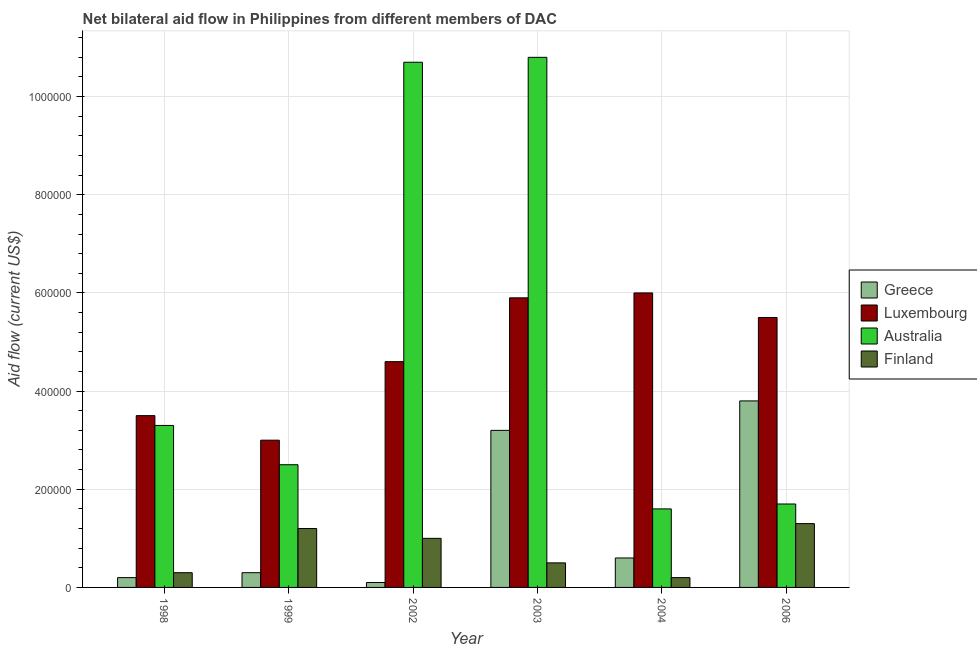Are the number of bars on each tick of the X-axis equal?
Give a very brief answer. Yes. How many bars are there on the 1st tick from the left?
Give a very brief answer. 4. What is the label of the 3rd group of bars from the left?
Your answer should be very brief. 2002. What is the amount of aid given by luxembourg in 2004?
Provide a short and direct response. 6.00e+05. Across all years, what is the maximum amount of aid given by finland?
Offer a very short reply. 1.30e+05. Across all years, what is the minimum amount of aid given by australia?
Offer a terse response. 1.60e+05. What is the total amount of aid given by greece in the graph?
Your response must be concise. 8.20e+05. What is the difference between the amount of aid given by luxembourg in 2002 and that in 2004?
Your response must be concise. -1.40e+05. What is the difference between the amount of aid given by luxembourg in 1998 and the amount of aid given by greece in 2006?
Give a very brief answer. -2.00e+05. What is the average amount of aid given by australia per year?
Provide a succinct answer. 5.10e+05. In the year 2004, what is the difference between the amount of aid given by australia and amount of aid given by finland?
Your answer should be compact. 0. In how many years, is the amount of aid given by finland greater than 960000 US$?
Provide a short and direct response. 0. What is the ratio of the amount of aid given by finland in 1998 to that in 2006?
Ensure brevity in your answer.  0.23. Is the amount of aid given by australia in 2003 less than that in 2004?
Offer a very short reply. No. Is the difference between the amount of aid given by finland in 2003 and 2006 greater than the difference between the amount of aid given by luxembourg in 2003 and 2006?
Ensure brevity in your answer.  No. What is the difference between the highest and the lowest amount of aid given by australia?
Your response must be concise. 9.20e+05. In how many years, is the amount of aid given by australia greater than the average amount of aid given by australia taken over all years?
Your answer should be very brief. 2. What does the 2nd bar from the left in 1999 represents?
Your response must be concise. Luxembourg. What does the 1st bar from the right in 1999 represents?
Your answer should be very brief. Finland. Is it the case that in every year, the sum of the amount of aid given by greece and amount of aid given by luxembourg is greater than the amount of aid given by australia?
Offer a terse response. No. Are all the bars in the graph horizontal?
Keep it short and to the point. No. How many years are there in the graph?
Offer a very short reply. 6. What is the difference between two consecutive major ticks on the Y-axis?
Your response must be concise. 2.00e+05. Are the values on the major ticks of Y-axis written in scientific E-notation?
Your answer should be compact. No. Does the graph contain any zero values?
Your response must be concise. No. Does the graph contain grids?
Your response must be concise. Yes. Where does the legend appear in the graph?
Give a very brief answer. Center right. How many legend labels are there?
Offer a very short reply. 4. What is the title of the graph?
Your answer should be compact. Net bilateral aid flow in Philippines from different members of DAC. What is the label or title of the X-axis?
Provide a succinct answer. Year. What is the label or title of the Y-axis?
Your answer should be compact. Aid flow (current US$). What is the Aid flow (current US$) of Greece in 1998?
Your answer should be very brief. 2.00e+04. What is the Aid flow (current US$) of Luxembourg in 1998?
Give a very brief answer. 3.50e+05. What is the Aid flow (current US$) of Luxembourg in 1999?
Offer a very short reply. 3.00e+05. What is the Aid flow (current US$) in Australia in 1999?
Provide a short and direct response. 2.50e+05. What is the Aid flow (current US$) of Finland in 1999?
Your answer should be very brief. 1.20e+05. What is the Aid flow (current US$) of Luxembourg in 2002?
Offer a terse response. 4.60e+05. What is the Aid flow (current US$) of Australia in 2002?
Keep it short and to the point. 1.07e+06. What is the Aid flow (current US$) in Luxembourg in 2003?
Make the answer very short. 5.90e+05. What is the Aid flow (current US$) in Australia in 2003?
Give a very brief answer. 1.08e+06. What is the Aid flow (current US$) of Finland in 2004?
Make the answer very short. 2.00e+04. What is the Aid flow (current US$) of Greece in 2006?
Offer a terse response. 3.80e+05. What is the Aid flow (current US$) of Australia in 2006?
Ensure brevity in your answer.  1.70e+05. What is the Aid flow (current US$) in Finland in 2006?
Provide a succinct answer. 1.30e+05. Across all years, what is the maximum Aid flow (current US$) in Luxembourg?
Your answer should be compact. 6.00e+05. Across all years, what is the maximum Aid flow (current US$) in Australia?
Your answer should be compact. 1.08e+06. Across all years, what is the minimum Aid flow (current US$) of Greece?
Ensure brevity in your answer.  10000. Across all years, what is the minimum Aid flow (current US$) in Luxembourg?
Keep it short and to the point. 3.00e+05. Across all years, what is the minimum Aid flow (current US$) in Australia?
Give a very brief answer. 1.60e+05. What is the total Aid flow (current US$) in Greece in the graph?
Your answer should be compact. 8.20e+05. What is the total Aid flow (current US$) of Luxembourg in the graph?
Offer a very short reply. 2.85e+06. What is the total Aid flow (current US$) in Australia in the graph?
Offer a very short reply. 3.06e+06. What is the total Aid flow (current US$) of Finland in the graph?
Provide a succinct answer. 4.50e+05. What is the difference between the Aid flow (current US$) of Luxembourg in 1998 and that in 1999?
Make the answer very short. 5.00e+04. What is the difference between the Aid flow (current US$) of Finland in 1998 and that in 1999?
Give a very brief answer. -9.00e+04. What is the difference between the Aid flow (current US$) of Australia in 1998 and that in 2002?
Your answer should be compact. -7.40e+05. What is the difference between the Aid flow (current US$) in Australia in 1998 and that in 2003?
Provide a succinct answer. -7.50e+05. What is the difference between the Aid flow (current US$) of Luxembourg in 1998 and that in 2004?
Offer a very short reply. -2.50e+05. What is the difference between the Aid flow (current US$) of Finland in 1998 and that in 2004?
Offer a terse response. 10000. What is the difference between the Aid flow (current US$) in Greece in 1998 and that in 2006?
Give a very brief answer. -3.60e+05. What is the difference between the Aid flow (current US$) of Luxembourg in 1998 and that in 2006?
Offer a terse response. -2.00e+05. What is the difference between the Aid flow (current US$) in Australia in 1998 and that in 2006?
Keep it short and to the point. 1.60e+05. What is the difference between the Aid flow (current US$) in Greece in 1999 and that in 2002?
Provide a succinct answer. 2.00e+04. What is the difference between the Aid flow (current US$) of Australia in 1999 and that in 2002?
Keep it short and to the point. -8.20e+05. What is the difference between the Aid flow (current US$) in Finland in 1999 and that in 2002?
Ensure brevity in your answer.  2.00e+04. What is the difference between the Aid flow (current US$) in Australia in 1999 and that in 2003?
Give a very brief answer. -8.30e+05. What is the difference between the Aid flow (current US$) in Australia in 1999 and that in 2004?
Offer a very short reply. 9.00e+04. What is the difference between the Aid flow (current US$) in Greece in 1999 and that in 2006?
Your answer should be compact. -3.50e+05. What is the difference between the Aid flow (current US$) of Greece in 2002 and that in 2003?
Provide a short and direct response. -3.10e+05. What is the difference between the Aid flow (current US$) of Finland in 2002 and that in 2003?
Your answer should be compact. 5.00e+04. What is the difference between the Aid flow (current US$) of Luxembourg in 2002 and that in 2004?
Give a very brief answer. -1.40e+05. What is the difference between the Aid flow (current US$) in Australia in 2002 and that in 2004?
Provide a succinct answer. 9.10e+05. What is the difference between the Aid flow (current US$) in Greece in 2002 and that in 2006?
Give a very brief answer. -3.70e+05. What is the difference between the Aid flow (current US$) in Australia in 2002 and that in 2006?
Your answer should be very brief. 9.00e+05. What is the difference between the Aid flow (current US$) in Finland in 2002 and that in 2006?
Your response must be concise. -3.00e+04. What is the difference between the Aid flow (current US$) of Australia in 2003 and that in 2004?
Make the answer very short. 9.20e+05. What is the difference between the Aid flow (current US$) in Finland in 2003 and that in 2004?
Offer a very short reply. 3.00e+04. What is the difference between the Aid flow (current US$) in Australia in 2003 and that in 2006?
Offer a terse response. 9.10e+05. What is the difference between the Aid flow (current US$) in Greece in 2004 and that in 2006?
Provide a succinct answer. -3.20e+05. What is the difference between the Aid flow (current US$) in Australia in 2004 and that in 2006?
Your answer should be compact. -10000. What is the difference between the Aid flow (current US$) of Finland in 2004 and that in 2006?
Your response must be concise. -1.10e+05. What is the difference between the Aid flow (current US$) of Greece in 1998 and the Aid flow (current US$) of Luxembourg in 1999?
Provide a succinct answer. -2.80e+05. What is the difference between the Aid flow (current US$) of Greece in 1998 and the Aid flow (current US$) of Australia in 1999?
Keep it short and to the point. -2.30e+05. What is the difference between the Aid flow (current US$) of Luxembourg in 1998 and the Aid flow (current US$) of Australia in 1999?
Offer a terse response. 1.00e+05. What is the difference between the Aid flow (current US$) of Greece in 1998 and the Aid flow (current US$) of Luxembourg in 2002?
Make the answer very short. -4.40e+05. What is the difference between the Aid flow (current US$) of Greece in 1998 and the Aid flow (current US$) of Australia in 2002?
Provide a short and direct response. -1.05e+06. What is the difference between the Aid flow (current US$) in Luxembourg in 1998 and the Aid flow (current US$) in Australia in 2002?
Give a very brief answer. -7.20e+05. What is the difference between the Aid flow (current US$) in Luxembourg in 1998 and the Aid flow (current US$) in Finland in 2002?
Your response must be concise. 2.50e+05. What is the difference between the Aid flow (current US$) in Greece in 1998 and the Aid flow (current US$) in Luxembourg in 2003?
Offer a terse response. -5.70e+05. What is the difference between the Aid flow (current US$) in Greece in 1998 and the Aid flow (current US$) in Australia in 2003?
Offer a terse response. -1.06e+06. What is the difference between the Aid flow (current US$) of Luxembourg in 1998 and the Aid flow (current US$) of Australia in 2003?
Give a very brief answer. -7.30e+05. What is the difference between the Aid flow (current US$) in Luxembourg in 1998 and the Aid flow (current US$) in Finland in 2003?
Make the answer very short. 3.00e+05. What is the difference between the Aid flow (current US$) in Australia in 1998 and the Aid flow (current US$) in Finland in 2003?
Give a very brief answer. 2.80e+05. What is the difference between the Aid flow (current US$) of Greece in 1998 and the Aid flow (current US$) of Luxembourg in 2004?
Your response must be concise. -5.80e+05. What is the difference between the Aid flow (current US$) in Australia in 1998 and the Aid flow (current US$) in Finland in 2004?
Offer a terse response. 3.10e+05. What is the difference between the Aid flow (current US$) in Greece in 1998 and the Aid flow (current US$) in Luxembourg in 2006?
Offer a terse response. -5.30e+05. What is the difference between the Aid flow (current US$) in Greece in 1998 and the Aid flow (current US$) in Finland in 2006?
Give a very brief answer. -1.10e+05. What is the difference between the Aid flow (current US$) of Luxembourg in 1998 and the Aid flow (current US$) of Australia in 2006?
Your answer should be compact. 1.80e+05. What is the difference between the Aid flow (current US$) in Australia in 1998 and the Aid flow (current US$) in Finland in 2006?
Give a very brief answer. 2.00e+05. What is the difference between the Aid flow (current US$) of Greece in 1999 and the Aid flow (current US$) of Luxembourg in 2002?
Ensure brevity in your answer.  -4.30e+05. What is the difference between the Aid flow (current US$) in Greece in 1999 and the Aid flow (current US$) in Australia in 2002?
Keep it short and to the point. -1.04e+06. What is the difference between the Aid flow (current US$) in Luxembourg in 1999 and the Aid flow (current US$) in Australia in 2002?
Keep it short and to the point. -7.70e+05. What is the difference between the Aid flow (current US$) of Greece in 1999 and the Aid flow (current US$) of Luxembourg in 2003?
Provide a succinct answer. -5.60e+05. What is the difference between the Aid flow (current US$) of Greece in 1999 and the Aid flow (current US$) of Australia in 2003?
Keep it short and to the point. -1.05e+06. What is the difference between the Aid flow (current US$) in Greece in 1999 and the Aid flow (current US$) in Finland in 2003?
Your answer should be very brief. -2.00e+04. What is the difference between the Aid flow (current US$) in Luxembourg in 1999 and the Aid flow (current US$) in Australia in 2003?
Your answer should be compact. -7.80e+05. What is the difference between the Aid flow (current US$) in Greece in 1999 and the Aid flow (current US$) in Luxembourg in 2004?
Your response must be concise. -5.70e+05. What is the difference between the Aid flow (current US$) of Greece in 1999 and the Aid flow (current US$) of Australia in 2004?
Provide a short and direct response. -1.30e+05. What is the difference between the Aid flow (current US$) in Luxembourg in 1999 and the Aid flow (current US$) in Australia in 2004?
Provide a short and direct response. 1.40e+05. What is the difference between the Aid flow (current US$) in Australia in 1999 and the Aid flow (current US$) in Finland in 2004?
Offer a very short reply. 2.30e+05. What is the difference between the Aid flow (current US$) of Greece in 1999 and the Aid flow (current US$) of Luxembourg in 2006?
Offer a very short reply. -5.20e+05. What is the difference between the Aid flow (current US$) of Greece in 1999 and the Aid flow (current US$) of Australia in 2006?
Make the answer very short. -1.40e+05. What is the difference between the Aid flow (current US$) in Luxembourg in 1999 and the Aid flow (current US$) in Australia in 2006?
Your answer should be compact. 1.30e+05. What is the difference between the Aid flow (current US$) in Australia in 1999 and the Aid flow (current US$) in Finland in 2006?
Ensure brevity in your answer.  1.20e+05. What is the difference between the Aid flow (current US$) of Greece in 2002 and the Aid flow (current US$) of Luxembourg in 2003?
Make the answer very short. -5.80e+05. What is the difference between the Aid flow (current US$) in Greece in 2002 and the Aid flow (current US$) in Australia in 2003?
Provide a short and direct response. -1.07e+06. What is the difference between the Aid flow (current US$) in Luxembourg in 2002 and the Aid flow (current US$) in Australia in 2003?
Provide a short and direct response. -6.20e+05. What is the difference between the Aid flow (current US$) in Australia in 2002 and the Aid flow (current US$) in Finland in 2003?
Keep it short and to the point. 1.02e+06. What is the difference between the Aid flow (current US$) of Greece in 2002 and the Aid flow (current US$) of Luxembourg in 2004?
Keep it short and to the point. -5.90e+05. What is the difference between the Aid flow (current US$) of Luxembourg in 2002 and the Aid flow (current US$) of Australia in 2004?
Provide a short and direct response. 3.00e+05. What is the difference between the Aid flow (current US$) in Luxembourg in 2002 and the Aid flow (current US$) in Finland in 2004?
Give a very brief answer. 4.40e+05. What is the difference between the Aid flow (current US$) in Australia in 2002 and the Aid flow (current US$) in Finland in 2004?
Ensure brevity in your answer.  1.05e+06. What is the difference between the Aid flow (current US$) of Greece in 2002 and the Aid flow (current US$) of Luxembourg in 2006?
Ensure brevity in your answer.  -5.40e+05. What is the difference between the Aid flow (current US$) of Greece in 2002 and the Aid flow (current US$) of Australia in 2006?
Provide a short and direct response. -1.60e+05. What is the difference between the Aid flow (current US$) in Luxembourg in 2002 and the Aid flow (current US$) in Australia in 2006?
Your answer should be very brief. 2.90e+05. What is the difference between the Aid flow (current US$) in Australia in 2002 and the Aid flow (current US$) in Finland in 2006?
Your response must be concise. 9.40e+05. What is the difference between the Aid flow (current US$) of Greece in 2003 and the Aid flow (current US$) of Luxembourg in 2004?
Your answer should be very brief. -2.80e+05. What is the difference between the Aid flow (current US$) of Greece in 2003 and the Aid flow (current US$) of Australia in 2004?
Provide a short and direct response. 1.60e+05. What is the difference between the Aid flow (current US$) in Luxembourg in 2003 and the Aid flow (current US$) in Finland in 2004?
Your answer should be compact. 5.70e+05. What is the difference between the Aid flow (current US$) in Australia in 2003 and the Aid flow (current US$) in Finland in 2004?
Make the answer very short. 1.06e+06. What is the difference between the Aid flow (current US$) of Luxembourg in 2003 and the Aid flow (current US$) of Finland in 2006?
Offer a very short reply. 4.60e+05. What is the difference between the Aid flow (current US$) of Australia in 2003 and the Aid flow (current US$) of Finland in 2006?
Provide a succinct answer. 9.50e+05. What is the difference between the Aid flow (current US$) of Greece in 2004 and the Aid flow (current US$) of Luxembourg in 2006?
Keep it short and to the point. -4.90e+05. What is the difference between the Aid flow (current US$) of Greece in 2004 and the Aid flow (current US$) of Australia in 2006?
Your answer should be very brief. -1.10e+05. What is the difference between the Aid flow (current US$) in Greece in 2004 and the Aid flow (current US$) in Finland in 2006?
Give a very brief answer. -7.00e+04. What is the difference between the Aid flow (current US$) in Australia in 2004 and the Aid flow (current US$) in Finland in 2006?
Ensure brevity in your answer.  3.00e+04. What is the average Aid flow (current US$) in Greece per year?
Offer a very short reply. 1.37e+05. What is the average Aid flow (current US$) of Luxembourg per year?
Your response must be concise. 4.75e+05. What is the average Aid flow (current US$) in Australia per year?
Your answer should be compact. 5.10e+05. What is the average Aid flow (current US$) of Finland per year?
Keep it short and to the point. 7.50e+04. In the year 1998, what is the difference between the Aid flow (current US$) in Greece and Aid flow (current US$) in Luxembourg?
Provide a short and direct response. -3.30e+05. In the year 1998, what is the difference between the Aid flow (current US$) of Greece and Aid flow (current US$) of Australia?
Keep it short and to the point. -3.10e+05. In the year 1998, what is the difference between the Aid flow (current US$) of Australia and Aid flow (current US$) of Finland?
Ensure brevity in your answer.  3.00e+05. In the year 1999, what is the difference between the Aid flow (current US$) in Greece and Aid flow (current US$) in Australia?
Provide a short and direct response. -2.20e+05. In the year 1999, what is the difference between the Aid flow (current US$) in Greece and Aid flow (current US$) in Finland?
Your response must be concise. -9.00e+04. In the year 1999, what is the difference between the Aid flow (current US$) of Luxembourg and Aid flow (current US$) of Australia?
Offer a very short reply. 5.00e+04. In the year 2002, what is the difference between the Aid flow (current US$) of Greece and Aid flow (current US$) of Luxembourg?
Offer a terse response. -4.50e+05. In the year 2002, what is the difference between the Aid flow (current US$) of Greece and Aid flow (current US$) of Australia?
Offer a terse response. -1.06e+06. In the year 2002, what is the difference between the Aid flow (current US$) of Luxembourg and Aid flow (current US$) of Australia?
Ensure brevity in your answer.  -6.10e+05. In the year 2002, what is the difference between the Aid flow (current US$) in Australia and Aid flow (current US$) in Finland?
Make the answer very short. 9.70e+05. In the year 2003, what is the difference between the Aid flow (current US$) of Greece and Aid flow (current US$) of Australia?
Keep it short and to the point. -7.60e+05. In the year 2003, what is the difference between the Aid flow (current US$) of Greece and Aid flow (current US$) of Finland?
Your answer should be compact. 2.70e+05. In the year 2003, what is the difference between the Aid flow (current US$) in Luxembourg and Aid flow (current US$) in Australia?
Your response must be concise. -4.90e+05. In the year 2003, what is the difference between the Aid flow (current US$) of Luxembourg and Aid flow (current US$) of Finland?
Offer a very short reply. 5.40e+05. In the year 2003, what is the difference between the Aid flow (current US$) in Australia and Aid flow (current US$) in Finland?
Offer a terse response. 1.03e+06. In the year 2004, what is the difference between the Aid flow (current US$) in Greece and Aid flow (current US$) in Luxembourg?
Give a very brief answer. -5.40e+05. In the year 2004, what is the difference between the Aid flow (current US$) of Greece and Aid flow (current US$) of Australia?
Offer a terse response. -1.00e+05. In the year 2004, what is the difference between the Aid flow (current US$) of Luxembourg and Aid flow (current US$) of Australia?
Your answer should be compact. 4.40e+05. In the year 2004, what is the difference between the Aid flow (current US$) in Luxembourg and Aid flow (current US$) in Finland?
Give a very brief answer. 5.80e+05. In the year 2004, what is the difference between the Aid flow (current US$) in Australia and Aid flow (current US$) in Finland?
Offer a very short reply. 1.40e+05. In the year 2006, what is the difference between the Aid flow (current US$) of Greece and Aid flow (current US$) of Finland?
Provide a succinct answer. 2.50e+05. In the year 2006, what is the difference between the Aid flow (current US$) of Luxembourg and Aid flow (current US$) of Australia?
Provide a short and direct response. 3.80e+05. In the year 2006, what is the difference between the Aid flow (current US$) of Luxembourg and Aid flow (current US$) of Finland?
Provide a succinct answer. 4.20e+05. In the year 2006, what is the difference between the Aid flow (current US$) in Australia and Aid flow (current US$) in Finland?
Your answer should be compact. 4.00e+04. What is the ratio of the Aid flow (current US$) of Luxembourg in 1998 to that in 1999?
Your response must be concise. 1.17. What is the ratio of the Aid flow (current US$) of Australia in 1998 to that in 1999?
Provide a succinct answer. 1.32. What is the ratio of the Aid flow (current US$) of Greece in 1998 to that in 2002?
Provide a short and direct response. 2. What is the ratio of the Aid flow (current US$) of Luxembourg in 1998 to that in 2002?
Your answer should be very brief. 0.76. What is the ratio of the Aid flow (current US$) in Australia in 1998 to that in 2002?
Provide a short and direct response. 0.31. What is the ratio of the Aid flow (current US$) of Greece in 1998 to that in 2003?
Your response must be concise. 0.06. What is the ratio of the Aid flow (current US$) in Luxembourg in 1998 to that in 2003?
Give a very brief answer. 0.59. What is the ratio of the Aid flow (current US$) of Australia in 1998 to that in 2003?
Provide a succinct answer. 0.31. What is the ratio of the Aid flow (current US$) of Finland in 1998 to that in 2003?
Ensure brevity in your answer.  0.6. What is the ratio of the Aid flow (current US$) in Luxembourg in 1998 to that in 2004?
Keep it short and to the point. 0.58. What is the ratio of the Aid flow (current US$) of Australia in 1998 to that in 2004?
Ensure brevity in your answer.  2.06. What is the ratio of the Aid flow (current US$) in Greece in 1998 to that in 2006?
Your response must be concise. 0.05. What is the ratio of the Aid flow (current US$) in Luxembourg in 1998 to that in 2006?
Your response must be concise. 0.64. What is the ratio of the Aid flow (current US$) of Australia in 1998 to that in 2006?
Offer a very short reply. 1.94. What is the ratio of the Aid flow (current US$) of Finland in 1998 to that in 2006?
Provide a succinct answer. 0.23. What is the ratio of the Aid flow (current US$) of Luxembourg in 1999 to that in 2002?
Ensure brevity in your answer.  0.65. What is the ratio of the Aid flow (current US$) in Australia in 1999 to that in 2002?
Ensure brevity in your answer.  0.23. What is the ratio of the Aid flow (current US$) in Finland in 1999 to that in 2002?
Give a very brief answer. 1.2. What is the ratio of the Aid flow (current US$) of Greece in 1999 to that in 2003?
Keep it short and to the point. 0.09. What is the ratio of the Aid flow (current US$) of Luxembourg in 1999 to that in 2003?
Ensure brevity in your answer.  0.51. What is the ratio of the Aid flow (current US$) of Australia in 1999 to that in 2003?
Ensure brevity in your answer.  0.23. What is the ratio of the Aid flow (current US$) of Finland in 1999 to that in 2003?
Your response must be concise. 2.4. What is the ratio of the Aid flow (current US$) of Australia in 1999 to that in 2004?
Give a very brief answer. 1.56. What is the ratio of the Aid flow (current US$) in Finland in 1999 to that in 2004?
Your response must be concise. 6. What is the ratio of the Aid flow (current US$) of Greece in 1999 to that in 2006?
Your answer should be very brief. 0.08. What is the ratio of the Aid flow (current US$) of Luxembourg in 1999 to that in 2006?
Keep it short and to the point. 0.55. What is the ratio of the Aid flow (current US$) of Australia in 1999 to that in 2006?
Your answer should be compact. 1.47. What is the ratio of the Aid flow (current US$) in Finland in 1999 to that in 2006?
Make the answer very short. 0.92. What is the ratio of the Aid flow (current US$) of Greece in 2002 to that in 2003?
Your answer should be very brief. 0.03. What is the ratio of the Aid flow (current US$) of Luxembourg in 2002 to that in 2003?
Offer a terse response. 0.78. What is the ratio of the Aid flow (current US$) in Greece in 2002 to that in 2004?
Your response must be concise. 0.17. What is the ratio of the Aid flow (current US$) of Luxembourg in 2002 to that in 2004?
Offer a terse response. 0.77. What is the ratio of the Aid flow (current US$) of Australia in 2002 to that in 2004?
Your response must be concise. 6.69. What is the ratio of the Aid flow (current US$) of Finland in 2002 to that in 2004?
Give a very brief answer. 5. What is the ratio of the Aid flow (current US$) of Greece in 2002 to that in 2006?
Offer a very short reply. 0.03. What is the ratio of the Aid flow (current US$) in Luxembourg in 2002 to that in 2006?
Your answer should be very brief. 0.84. What is the ratio of the Aid flow (current US$) of Australia in 2002 to that in 2006?
Offer a very short reply. 6.29. What is the ratio of the Aid flow (current US$) of Finland in 2002 to that in 2006?
Offer a very short reply. 0.77. What is the ratio of the Aid flow (current US$) of Greece in 2003 to that in 2004?
Your answer should be very brief. 5.33. What is the ratio of the Aid flow (current US$) of Luxembourg in 2003 to that in 2004?
Your answer should be compact. 0.98. What is the ratio of the Aid flow (current US$) of Australia in 2003 to that in 2004?
Provide a succinct answer. 6.75. What is the ratio of the Aid flow (current US$) in Greece in 2003 to that in 2006?
Ensure brevity in your answer.  0.84. What is the ratio of the Aid flow (current US$) in Luxembourg in 2003 to that in 2006?
Your answer should be compact. 1.07. What is the ratio of the Aid flow (current US$) of Australia in 2003 to that in 2006?
Your answer should be compact. 6.35. What is the ratio of the Aid flow (current US$) of Finland in 2003 to that in 2006?
Offer a terse response. 0.38. What is the ratio of the Aid flow (current US$) of Greece in 2004 to that in 2006?
Your answer should be very brief. 0.16. What is the ratio of the Aid flow (current US$) of Australia in 2004 to that in 2006?
Provide a succinct answer. 0.94. What is the ratio of the Aid flow (current US$) of Finland in 2004 to that in 2006?
Offer a terse response. 0.15. What is the difference between the highest and the second highest Aid flow (current US$) in Finland?
Offer a terse response. 10000. What is the difference between the highest and the lowest Aid flow (current US$) of Greece?
Give a very brief answer. 3.70e+05. What is the difference between the highest and the lowest Aid flow (current US$) in Luxembourg?
Make the answer very short. 3.00e+05. What is the difference between the highest and the lowest Aid flow (current US$) of Australia?
Ensure brevity in your answer.  9.20e+05. What is the difference between the highest and the lowest Aid flow (current US$) of Finland?
Your answer should be very brief. 1.10e+05. 